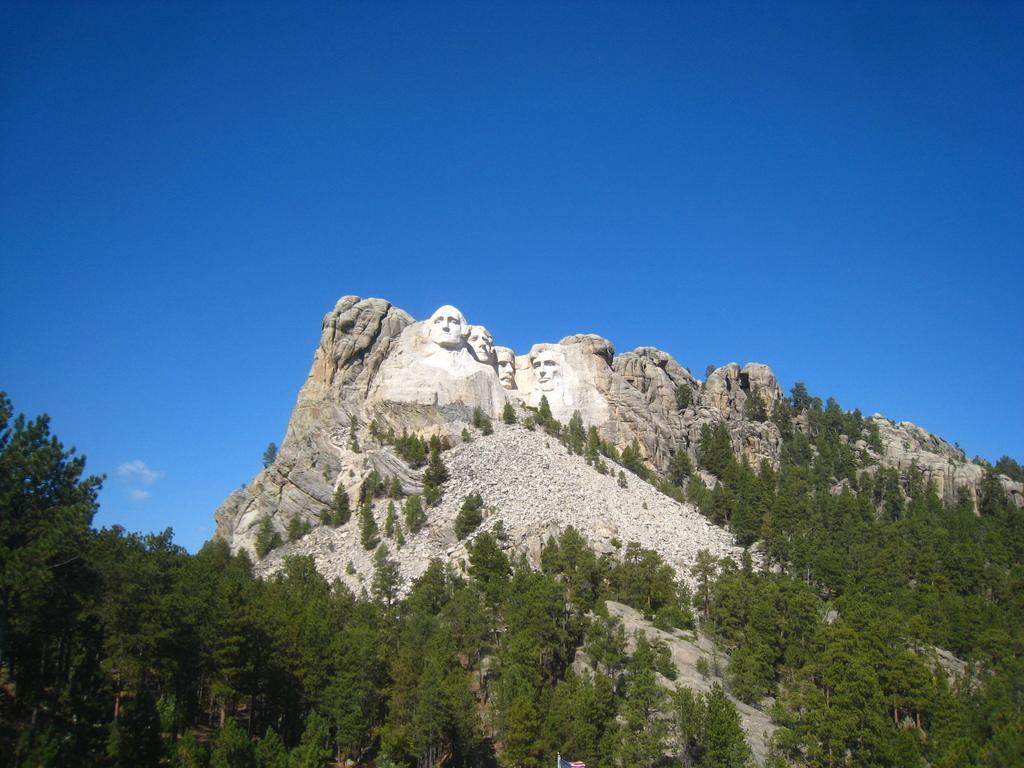Please provide a concise description of this image. In this image, we can see some trees. There are sculptures on hill which is in the middle of the image. There is a sky at the top of the image. 